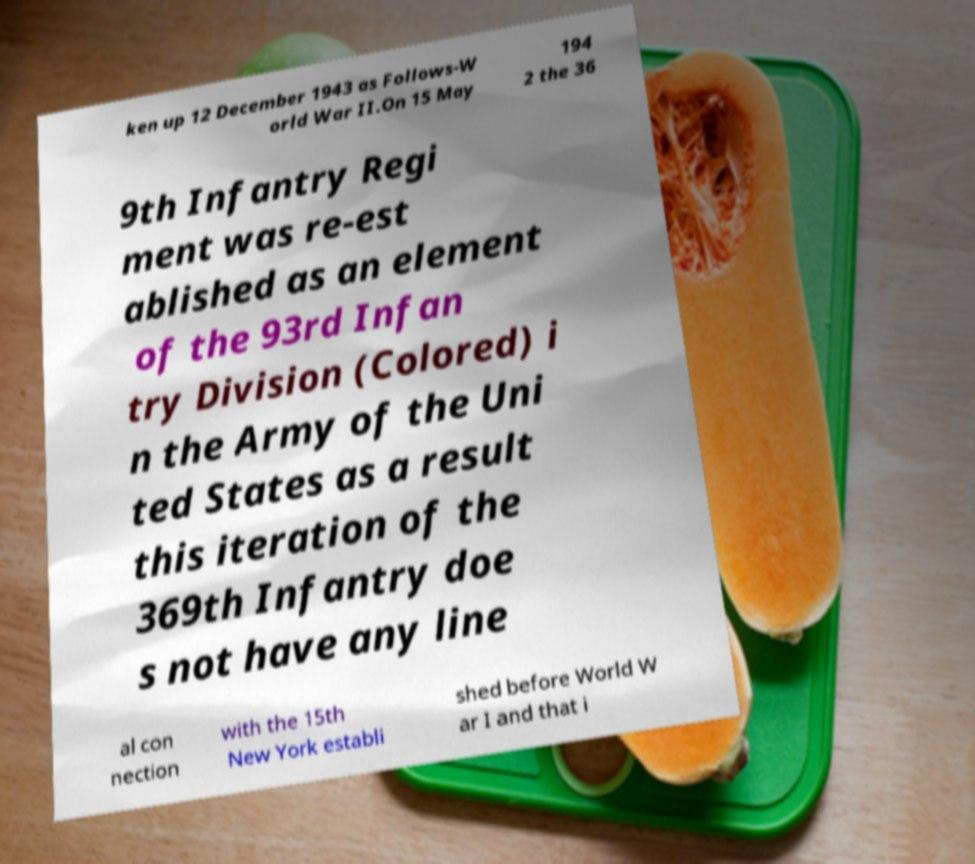Can you accurately transcribe the text from the provided image for me? ken up 12 December 1943 as Follows-W orld War II.On 15 May 194 2 the 36 9th Infantry Regi ment was re-est ablished as an element of the 93rd Infan try Division (Colored) i n the Army of the Uni ted States as a result this iteration of the 369th Infantry doe s not have any line al con nection with the 15th New York establi shed before World W ar I and that i 